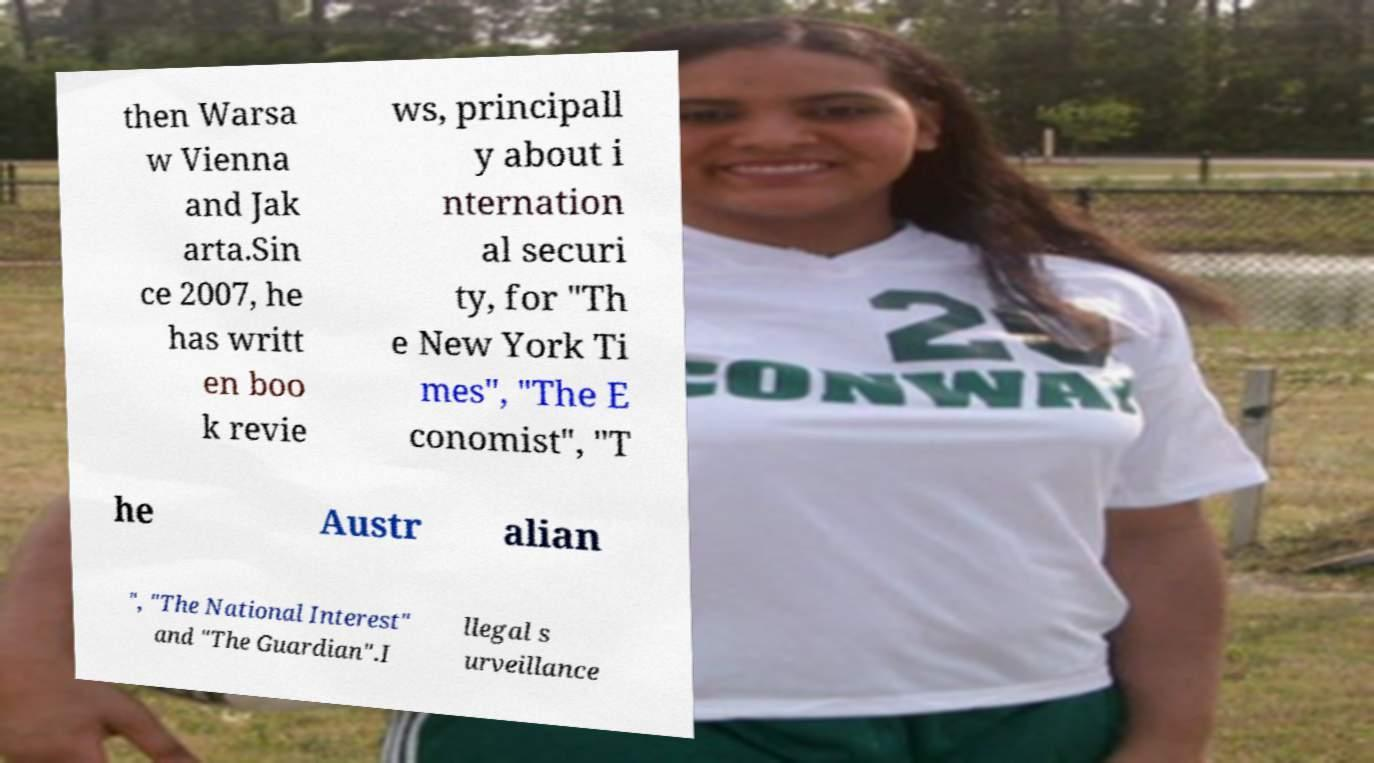I need the written content from this picture converted into text. Can you do that? then Warsa w Vienna and Jak arta.Sin ce 2007, he has writt en boo k revie ws, principall y about i nternation al securi ty, for "Th e New York Ti mes", "The E conomist", "T he Austr alian ", "The National Interest" and "The Guardian".I llegal s urveillance 